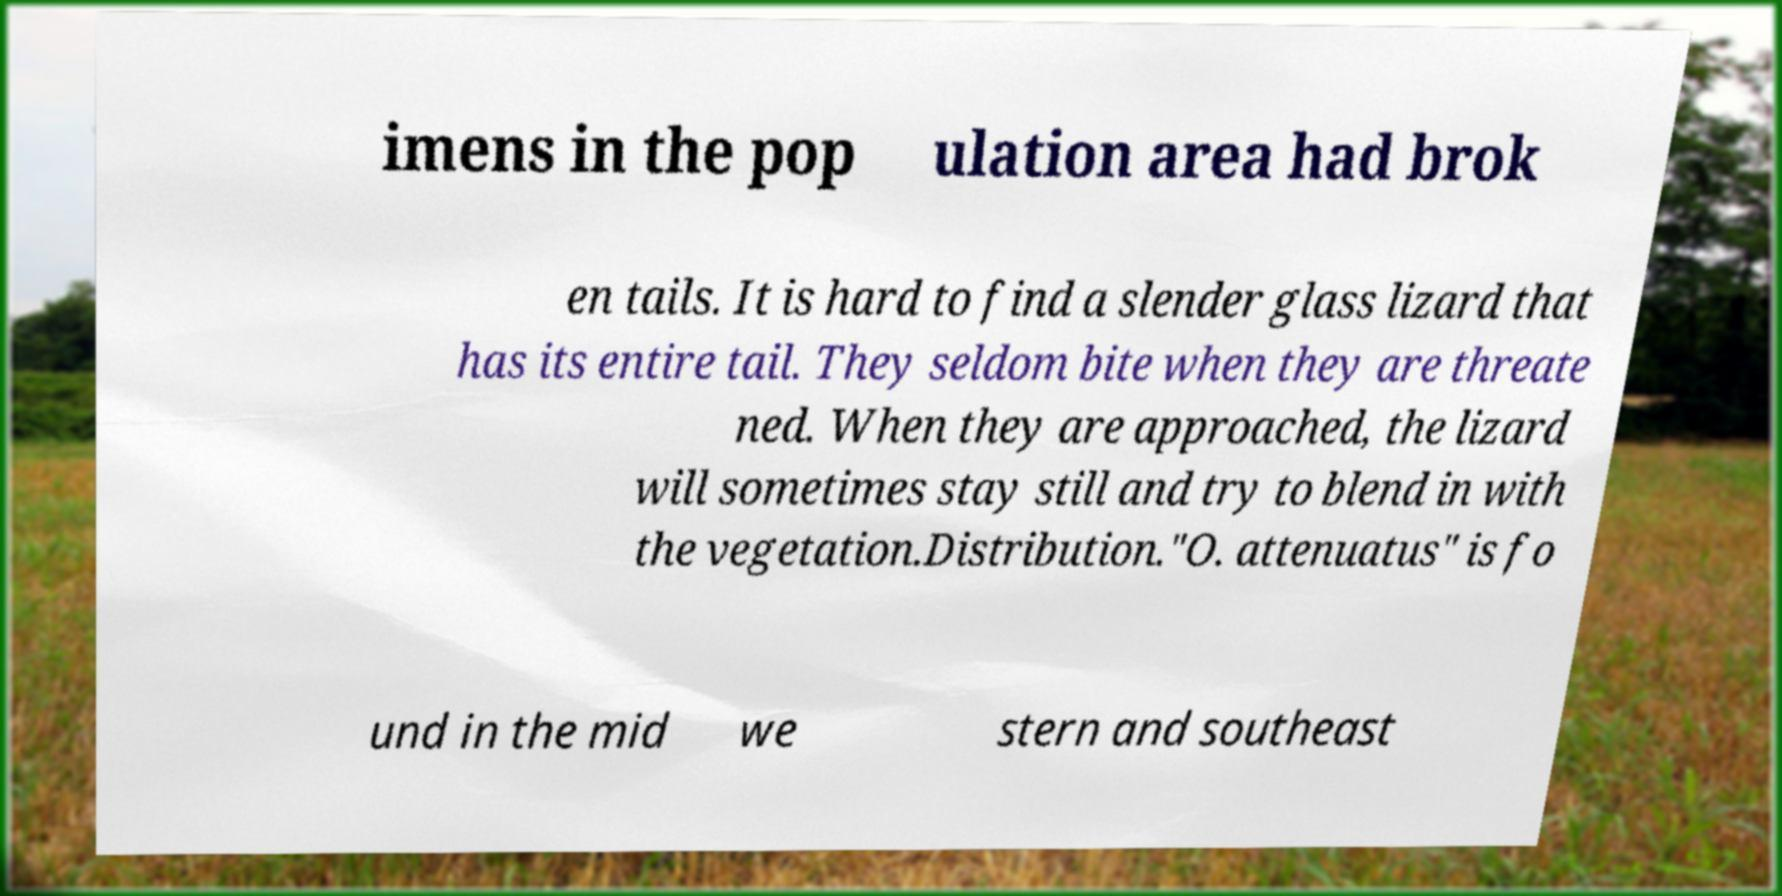Could you extract and type out the text from this image? imens in the pop ulation area had brok en tails. It is hard to find a slender glass lizard that has its entire tail. They seldom bite when they are threate ned. When they are approached, the lizard will sometimes stay still and try to blend in with the vegetation.Distribution."O. attenuatus" is fo und in the mid we stern and southeast 